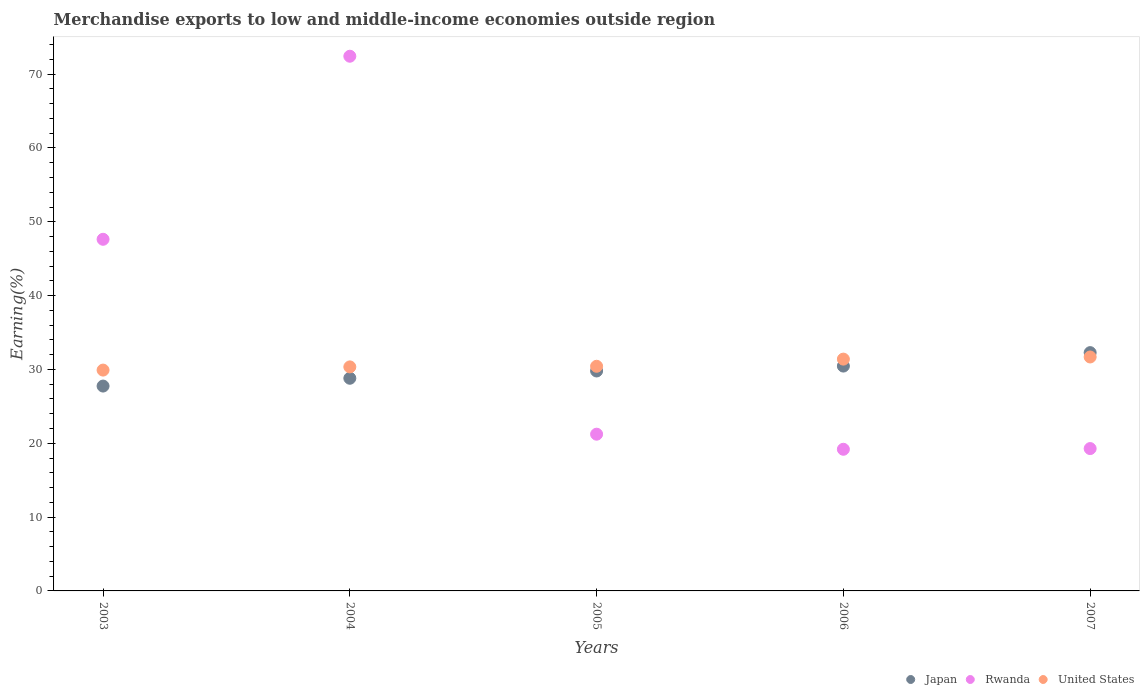How many different coloured dotlines are there?
Offer a terse response. 3. Is the number of dotlines equal to the number of legend labels?
Provide a short and direct response. Yes. What is the percentage of amount earned from merchandise exports in Japan in 2003?
Your response must be concise. 27.75. Across all years, what is the maximum percentage of amount earned from merchandise exports in Japan?
Offer a terse response. 32.28. Across all years, what is the minimum percentage of amount earned from merchandise exports in Rwanda?
Keep it short and to the point. 19.19. In which year was the percentage of amount earned from merchandise exports in Rwanda maximum?
Your answer should be compact. 2004. What is the total percentage of amount earned from merchandise exports in Japan in the graph?
Make the answer very short. 149.08. What is the difference between the percentage of amount earned from merchandise exports in United States in 2003 and that in 2004?
Give a very brief answer. -0.43. What is the difference between the percentage of amount earned from merchandise exports in United States in 2003 and the percentage of amount earned from merchandise exports in Rwanda in 2007?
Offer a very short reply. 10.63. What is the average percentage of amount earned from merchandise exports in Rwanda per year?
Provide a short and direct response. 35.95. In the year 2003, what is the difference between the percentage of amount earned from merchandise exports in Japan and percentage of amount earned from merchandise exports in United States?
Give a very brief answer. -2.16. In how many years, is the percentage of amount earned from merchandise exports in Japan greater than 54 %?
Your answer should be compact. 0. What is the ratio of the percentage of amount earned from merchandise exports in Japan in 2005 to that in 2006?
Make the answer very short. 0.98. What is the difference between the highest and the second highest percentage of amount earned from merchandise exports in United States?
Your answer should be compact. 0.29. What is the difference between the highest and the lowest percentage of amount earned from merchandise exports in Rwanda?
Provide a short and direct response. 53.24. Is the sum of the percentage of amount earned from merchandise exports in United States in 2004 and 2007 greater than the maximum percentage of amount earned from merchandise exports in Rwanda across all years?
Offer a very short reply. No. Is the percentage of amount earned from merchandise exports in Japan strictly greater than the percentage of amount earned from merchandise exports in United States over the years?
Make the answer very short. No. Is the percentage of amount earned from merchandise exports in United States strictly less than the percentage of amount earned from merchandise exports in Rwanda over the years?
Keep it short and to the point. No. How many dotlines are there?
Offer a very short reply. 3. How many years are there in the graph?
Provide a short and direct response. 5. Are the values on the major ticks of Y-axis written in scientific E-notation?
Provide a succinct answer. No. Does the graph contain any zero values?
Offer a terse response. No. Does the graph contain grids?
Make the answer very short. No. Where does the legend appear in the graph?
Keep it short and to the point. Bottom right. What is the title of the graph?
Offer a terse response. Merchandise exports to low and middle-income economies outside region. Does "Gabon" appear as one of the legend labels in the graph?
Offer a terse response. No. What is the label or title of the X-axis?
Your response must be concise. Years. What is the label or title of the Y-axis?
Ensure brevity in your answer.  Earning(%). What is the Earning(%) in Japan in 2003?
Give a very brief answer. 27.75. What is the Earning(%) of Rwanda in 2003?
Give a very brief answer. 47.63. What is the Earning(%) of United States in 2003?
Your answer should be compact. 29.91. What is the Earning(%) in Japan in 2004?
Your response must be concise. 28.8. What is the Earning(%) in Rwanda in 2004?
Give a very brief answer. 72.42. What is the Earning(%) in United States in 2004?
Keep it short and to the point. 30.35. What is the Earning(%) in Japan in 2005?
Keep it short and to the point. 29.79. What is the Earning(%) in Rwanda in 2005?
Provide a succinct answer. 21.23. What is the Earning(%) in United States in 2005?
Give a very brief answer. 30.43. What is the Earning(%) of Japan in 2006?
Ensure brevity in your answer.  30.46. What is the Earning(%) in Rwanda in 2006?
Provide a short and direct response. 19.19. What is the Earning(%) of United States in 2006?
Your response must be concise. 31.4. What is the Earning(%) of Japan in 2007?
Your answer should be very brief. 32.28. What is the Earning(%) in Rwanda in 2007?
Give a very brief answer. 19.28. What is the Earning(%) of United States in 2007?
Your response must be concise. 31.69. Across all years, what is the maximum Earning(%) in Japan?
Offer a terse response. 32.28. Across all years, what is the maximum Earning(%) in Rwanda?
Offer a terse response. 72.42. Across all years, what is the maximum Earning(%) of United States?
Keep it short and to the point. 31.69. Across all years, what is the minimum Earning(%) of Japan?
Provide a succinct answer. 27.75. Across all years, what is the minimum Earning(%) in Rwanda?
Offer a very short reply. 19.19. Across all years, what is the minimum Earning(%) in United States?
Your answer should be very brief. 29.91. What is the total Earning(%) in Japan in the graph?
Offer a very short reply. 149.08. What is the total Earning(%) in Rwanda in the graph?
Your answer should be very brief. 179.75. What is the total Earning(%) in United States in the graph?
Keep it short and to the point. 153.77. What is the difference between the Earning(%) in Japan in 2003 and that in 2004?
Offer a very short reply. -1.06. What is the difference between the Earning(%) of Rwanda in 2003 and that in 2004?
Your answer should be very brief. -24.8. What is the difference between the Earning(%) of United States in 2003 and that in 2004?
Make the answer very short. -0.43. What is the difference between the Earning(%) in Japan in 2003 and that in 2005?
Your response must be concise. -2.04. What is the difference between the Earning(%) of Rwanda in 2003 and that in 2005?
Provide a succinct answer. 26.4. What is the difference between the Earning(%) in United States in 2003 and that in 2005?
Your answer should be very brief. -0.52. What is the difference between the Earning(%) of Japan in 2003 and that in 2006?
Provide a succinct answer. -2.71. What is the difference between the Earning(%) of Rwanda in 2003 and that in 2006?
Offer a very short reply. 28.44. What is the difference between the Earning(%) of United States in 2003 and that in 2006?
Your answer should be compact. -1.49. What is the difference between the Earning(%) of Japan in 2003 and that in 2007?
Your answer should be very brief. -4.53. What is the difference between the Earning(%) of Rwanda in 2003 and that in 2007?
Your answer should be very brief. 28.35. What is the difference between the Earning(%) in United States in 2003 and that in 2007?
Offer a terse response. -1.78. What is the difference between the Earning(%) of Japan in 2004 and that in 2005?
Offer a very short reply. -0.99. What is the difference between the Earning(%) of Rwanda in 2004 and that in 2005?
Offer a very short reply. 51.19. What is the difference between the Earning(%) in United States in 2004 and that in 2005?
Keep it short and to the point. -0.08. What is the difference between the Earning(%) in Japan in 2004 and that in 2006?
Provide a succinct answer. -1.65. What is the difference between the Earning(%) in Rwanda in 2004 and that in 2006?
Provide a succinct answer. 53.24. What is the difference between the Earning(%) of United States in 2004 and that in 2006?
Ensure brevity in your answer.  -1.05. What is the difference between the Earning(%) in Japan in 2004 and that in 2007?
Keep it short and to the point. -3.47. What is the difference between the Earning(%) of Rwanda in 2004 and that in 2007?
Your response must be concise. 53.14. What is the difference between the Earning(%) in United States in 2004 and that in 2007?
Provide a short and direct response. -1.34. What is the difference between the Earning(%) in Japan in 2005 and that in 2006?
Offer a terse response. -0.66. What is the difference between the Earning(%) in Rwanda in 2005 and that in 2006?
Keep it short and to the point. 2.04. What is the difference between the Earning(%) in United States in 2005 and that in 2006?
Your answer should be compact. -0.97. What is the difference between the Earning(%) of Japan in 2005 and that in 2007?
Ensure brevity in your answer.  -2.49. What is the difference between the Earning(%) of Rwanda in 2005 and that in 2007?
Give a very brief answer. 1.95. What is the difference between the Earning(%) in United States in 2005 and that in 2007?
Your response must be concise. -1.26. What is the difference between the Earning(%) of Japan in 2006 and that in 2007?
Provide a short and direct response. -1.82. What is the difference between the Earning(%) of Rwanda in 2006 and that in 2007?
Provide a short and direct response. -0.1. What is the difference between the Earning(%) in United States in 2006 and that in 2007?
Your answer should be very brief. -0.29. What is the difference between the Earning(%) in Japan in 2003 and the Earning(%) in Rwanda in 2004?
Provide a succinct answer. -44.68. What is the difference between the Earning(%) in Japan in 2003 and the Earning(%) in United States in 2004?
Keep it short and to the point. -2.6. What is the difference between the Earning(%) in Rwanda in 2003 and the Earning(%) in United States in 2004?
Your response must be concise. 17.28. What is the difference between the Earning(%) in Japan in 2003 and the Earning(%) in Rwanda in 2005?
Your response must be concise. 6.52. What is the difference between the Earning(%) in Japan in 2003 and the Earning(%) in United States in 2005?
Your answer should be compact. -2.68. What is the difference between the Earning(%) of Rwanda in 2003 and the Earning(%) of United States in 2005?
Provide a short and direct response. 17.2. What is the difference between the Earning(%) of Japan in 2003 and the Earning(%) of Rwanda in 2006?
Your answer should be compact. 8.56. What is the difference between the Earning(%) of Japan in 2003 and the Earning(%) of United States in 2006?
Keep it short and to the point. -3.65. What is the difference between the Earning(%) in Rwanda in 2003 and the Earning(%) in United States in 2006?
Your answer should be very brief. 16.23. What is the difference between the Earning(%) of Japan in 2003 and the Earning(%) of Rwanda in 2007?
Your response must be concise. 8.47. What is the difference between the Earning(%) of Japan in 2003 and the Earning(%) of United States in 2007?
Give a very brief answer. -3.94. What is the difference between the Earning(%) of Rwanda in 2003 and the Earning(%) of United States in 2007?
Offer a very short reply. 15.94. What is the difference between the Earning(%) in Japan in 2004 and the Earning(%) in Rwanda in 2005?
Provide a short and direct response. 7.58. What is the difference between the Earning(%) of Japan in 2004 and the Earning(%) of United States in 2005?
Ensure brevity in your answer.  -1.62. What is the difference between the Earning(%) of Rwanda in 2004 and the Earning(%) of United States in 2005?
Offer a terse response. 42. What is the difference between the Earning(%) in Japan in 2004 and the Earning(%) in Rwanda in 2006?
Ensure brevity in your answer.  9.62. What is the difference between the Earning(%) in Japan in 2004 and the Earning(%) in United States in 2006?
Make the answer very short. -2.59. What is the difference between the Earning(%) of Rwanda in 2004 and the Earning(%) of United States in 2006?
Ensure brevity in your answer.  41.03. What is the difference between the Earning(%) in Japan in 2004 and the Earning(%) in Rwanda in 2007?
Give a very brief answer. 9.52. What is the difference between the Earning(%) of Japan in 2004 and the Earning(%) of United States in 2007?
Ensure brevity in your answer.  -2.88. What is the difference between the Earning(%) of Rwanda in 2004 and the Earning(%) of United States in 2007?
Offer a very short reply. 40.74. What is the difference between the Earning(%) in Japan in 2005 and the Earning(%) in Rwanda in 2006?
Provide a short and direct response. 10.6. What is the difference between the Earning(%) of Japan in 2005 and the Earning(%) of United States in 2006?
Provide a succinct answer. -1.61. What is the difference between the Earning(%) of Rwanda in 2005 and the Earning(%) of United States in 2006?
Keep it short and to the point. -10.17. What is the difference between the Earning(%) of Japan in 2005 and the Earning(%) of Rwanda in 2007?
Ensure brevity in your answer.  10.51. What is the difference between the Earning(%) in Japan in 2005 and the Earning(%) in United States in 2007?
Provide a succinct answer. -1.9. What is the difference between the Earning(%) in Rwanda in 2005 and the Earning(%) in United States in 2007?
Offer a terse response. -10.46. What is the difference between the Earning(%) of Japan in 2006 and the Earning(%) of Rwanda in 2007?
Keep it short and to the point. 11.17. What is the difference between the Earning(%) in Japan in 2006 and the Earning(%) in United States in 2007?
Ensure brevity in your answer.  -1.23. What is the difference between the Earning(%) in Rwanda in 2006 and the Earning(%) in United States in 2007?
Offer a terse response. -12.5. What is the average Earning(%) of Japan per year?
Provide a short and direct response. 29.82. What is the average Earning(%) of Rwanda per year?
Keep it short and to the point. 35.95. What is the average Earning(%) of United States per year?
Make the answer very short. 30.75. In the year 2003, what is the difference between the Earning(%) of Japan and Earning(%) of Rwanda?
Make the answer very short. -19.88. In the year 2003, what is the difference between the Earning(%) in Japan and Earning(%) in United States?
Your answer should be compact. -2.16. In the year 2003, what is the difference between the Earning(%) in Rwanda and Earning(%) in United States?
Ensure brevity in your answer.  17.72. In the year 2004, what is the difference between the Earning(%) of Japan and Earning(%) of Rwanda?
Ensure brevity in your answer.  -43.62. In the year 2004, what is the difference between the Earning(%) in Japan and Earning(%) in United States?
Provide a short and direct response. -1.54. In the year 2004, what is the difference between the Earning(%) in Rwanda and Earning(%) in United States?
Offer a very short reply. 42.08. In the year 2005, what is the difference between the Earning(%) in Japan and Earning(%) in Rwanda?
Provide a short and direct response. 8.56. In the year 2005, what is the difference between the Earning(%) in Japan and Earning(%) in United States?
Provide a short and direct response. -0.64. In the year 2005, what is the difference between the Earning(%) of Rwanda and Earning(%) of United States?
Ensure brevity in your answer.  -9.2. In the year 2006, what is the difference between the Earning(%) in Japan and Earning(%) in Rwanda?
Offer a terse response. 11.27. In the year 2006, what is the difference between the Earning(%) in Japan and Earning(%) in United States?
Keep it short and to the point. -0.94. In the year 2006, what is the difference between the Earning(%) of Rwanda and Earning(%) of United States?
Make the answer very short. -12.21. In the year 2007, what is the difference between the Earning(%) in Japan and Earning(%) in Rwanda?
Give a very brief answer. 13. In the year 2007, what is the difference between the Earning(%) in Japan and Earning(%) in United States?
Ensure brevity in your answer.  0.59. In the year 2007, what is the difference between the Earning(%) in Rwanda and Earning(%) in United States?
Your response must be concise. -12.41. What is the ratio of the Earning(%) of Japan in 2003 to that in 2004?
Your answer should be compact. 0.96. What is the ratio of the Earning(%) in Rwanda in 2003 to that in 2004?
Your response must be concise. 0.66. What is the ratio of the Earning(%) in United States in 2003 to that in 2004?
Your response must be concise. 0.99. What is the ratio of the Earning(%) of Japan in 2003 to that in 2005?
Provide a short and direct response. 0.93. What is the ratio of the Earning(%) of Rwanda in 2003 to that in 2005?
Your response must be concise. 2.24. What is the ratio of the Earning(%) in United States in 2003 to that in 2005?
Offer a terse response. 0.98. What is the ratio of the Earning(%) in Japan in 2003 to that in 2006?
Provide a short and direct response. 0.91. What is the ratio of the Earning(%) of Rwanda in 2003 to that in 2006?
Keep it short and to the point. 2.48. What is the ratio of the Earning(%) in United States in 2003 to that in 2006?
Your answer should be compact. 0.95. What is the ratio of the Earning(%) in Japan in 2003 to that in 2007?
Offer a very short reply. 0.86. What is the ratio of the Earning(%) of Rwanda in 2003 to that in 2007?
Provide a short and direct response. 2.47. What is the ratio of the Earning(%) of United States in 2003 to that in 2007?
Your answer should be very brief. 0.94. What is the ratio of the Earning(%) of Japan in 2004 to that in 2005?
Your answer should be very brief. 0.97. What is the ratio of the Earning(%) in Rwanda in 2004 to that in 2005?
Keep it short and to the point. 3.41. What is the ratio of the Earning(%) in Japan in 2004 to that in 2006?
Your answer should be very brief. 0.95. What is the ratio of the Earning(%) of Rwanda in 2004 to that in 2006?
Keep it short and to the point. 3.77. What is the ratio of the Earning(%) in United States in 2004 to that in 2006?
Ensure brevity in your answer.  0.97. What is the ratio of the Earning(%) in Japan in 2004 to that in 2007?
Provide a succinct answer. 0.89. What is the ratio of the Earning(%) of Rwanda in 2004 to that in 2007?
Offer a very short reply. 3.76. What is the ratio of the Earning(%) of United States in 2004 to that in 2007?
Keep it short and to the point. 0.96. What is the ratio of the Earning(%) of Japan in 2005 to that in 2006?
Keep it short and to the point. 0.98. What is the ratio of the Earning(%) in Rwanda in 2005 to that in 2006?
Your answer should be compact. 1.11. What is the ratio of the Earning(%) in United States in 2005 to that in 2006?
Give a very brief answer. 0.97. What is the ratio of the Earning(%) in Japan in 2005 to that in 2007?
Ensure brevity in your answer.  0.92. What is the ratio of the Earning(%) of Rwanda in 2005 to that in 2007?
Offer a very short reply. 1.1. What is the ratio of the Earning(%) of United States in 2005 to that in 2007?
Ensure brevity in your answer.  0.96. What is the ratio of the Earning(%) of Japan in 2006 to that in 2007?
Offer a very short reply. 0.94. What is the ratio of the Earning(%) of United States in 2006 to that in 2007?
Give a very brief answer. 0.99. What is the difference between the highest and the second highest Earning(%) of Japan?
Give a very brief answer. 1.82. What is the difference between the highest and the second highest Earning(%) of Rwanda?
Your answer should be compact. 24.8. What is the difference between the highest and the second highest Earning(%) of United States?
Offer a terse response. 0.29. What is the difference between the highest and the lowest Earning(%) in Japan?
Your response must be concise. 4.53. What is the difference between the highest and the lowest Earning(%) of Rwanda?
Make the answer very short. 53.24. What is the difference between the highest and the lowest Earning(%) of United States?
Provide a succinct answer. 1.78. 